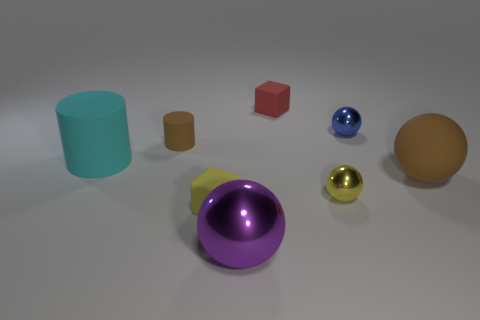Does the tiny matte cylinder have the same color as the big matte ball?
Ensure brevity in your answer.  Yes. Is the number of tiny spheres that are right of the tiny red thing the same as the number of tiny blocks that are to the right of the big cyan object?
Give a very brief answer. Yes. There is a metal ball behind the small yellow metal object; is its size the same as the yellow metal ball behind the small yellow rubber object?
Keep it short and to the point. Yes. The yellow thing left of the rubber thing that is behind the tiny sphere that is behind the large cylinder is what shape?
Your answer should be very brief. Cube. What is the size of the other rubber object that is the same shape as the tiny brown rubber thing?
Provide a short and direct response. Large. There is a big thing that is both to the left of the big brown object and right of the large cyan object; what is its color?
Provide a succinct answer. Purple. Are the big brown ball and the small cube that is in front of the cyan cylinder made of the same material?
Offer a very short reply. Yes. Is the number of brown spheres that are left of the yellow matte object less than the number of tiny red things?
Provide a short and direct response. Yes. How many other things are there of the same shape as the big metallic object?
Ensure brevity in your answer.  3. Is there anything else that is the same color as the big metallic object?
Offer a terse response. No. 